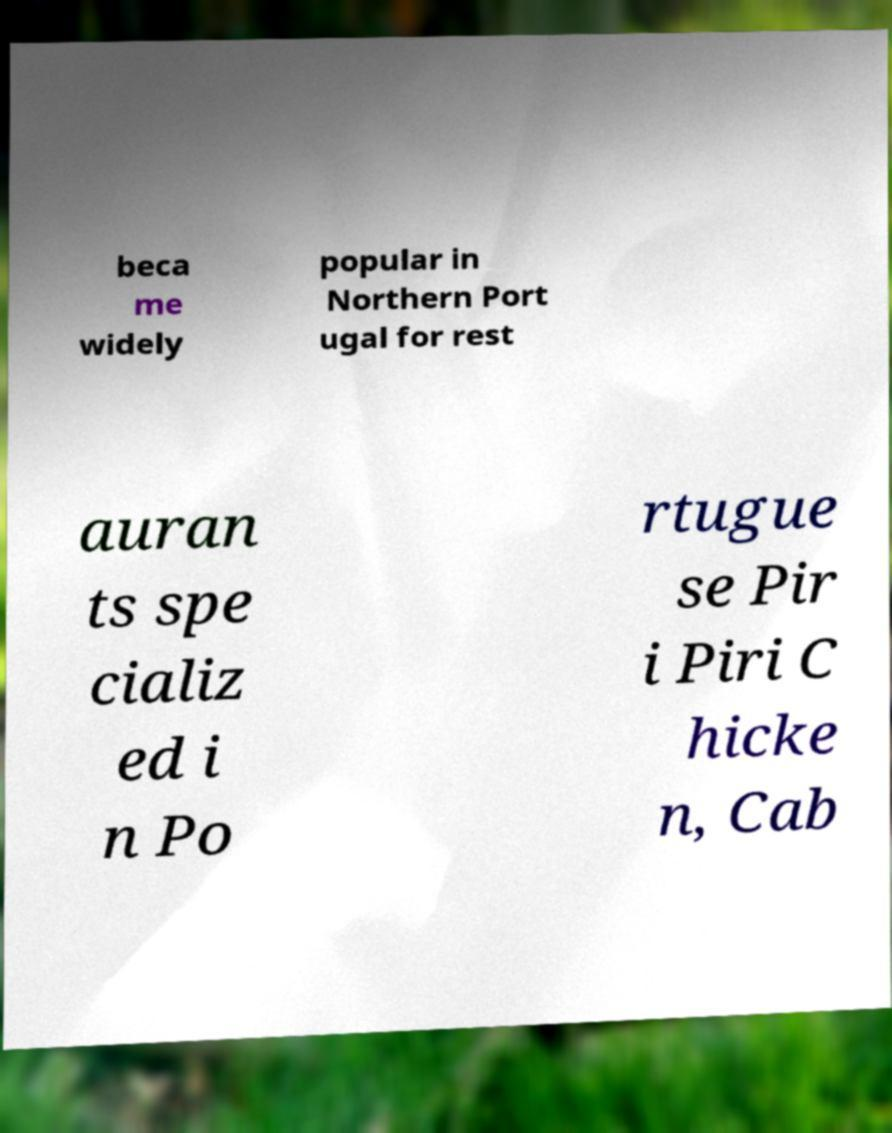Please identify and transcribe the text found in this image. beca me widely popular in Northern Port ugal for rest auran ts spe cializ ed i n Po rtugue se Pir i Piri C hicke n, Cab 